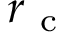<formula> <loc_0><loc_0><loc_500><loc_500>r _ { c }</formula> 